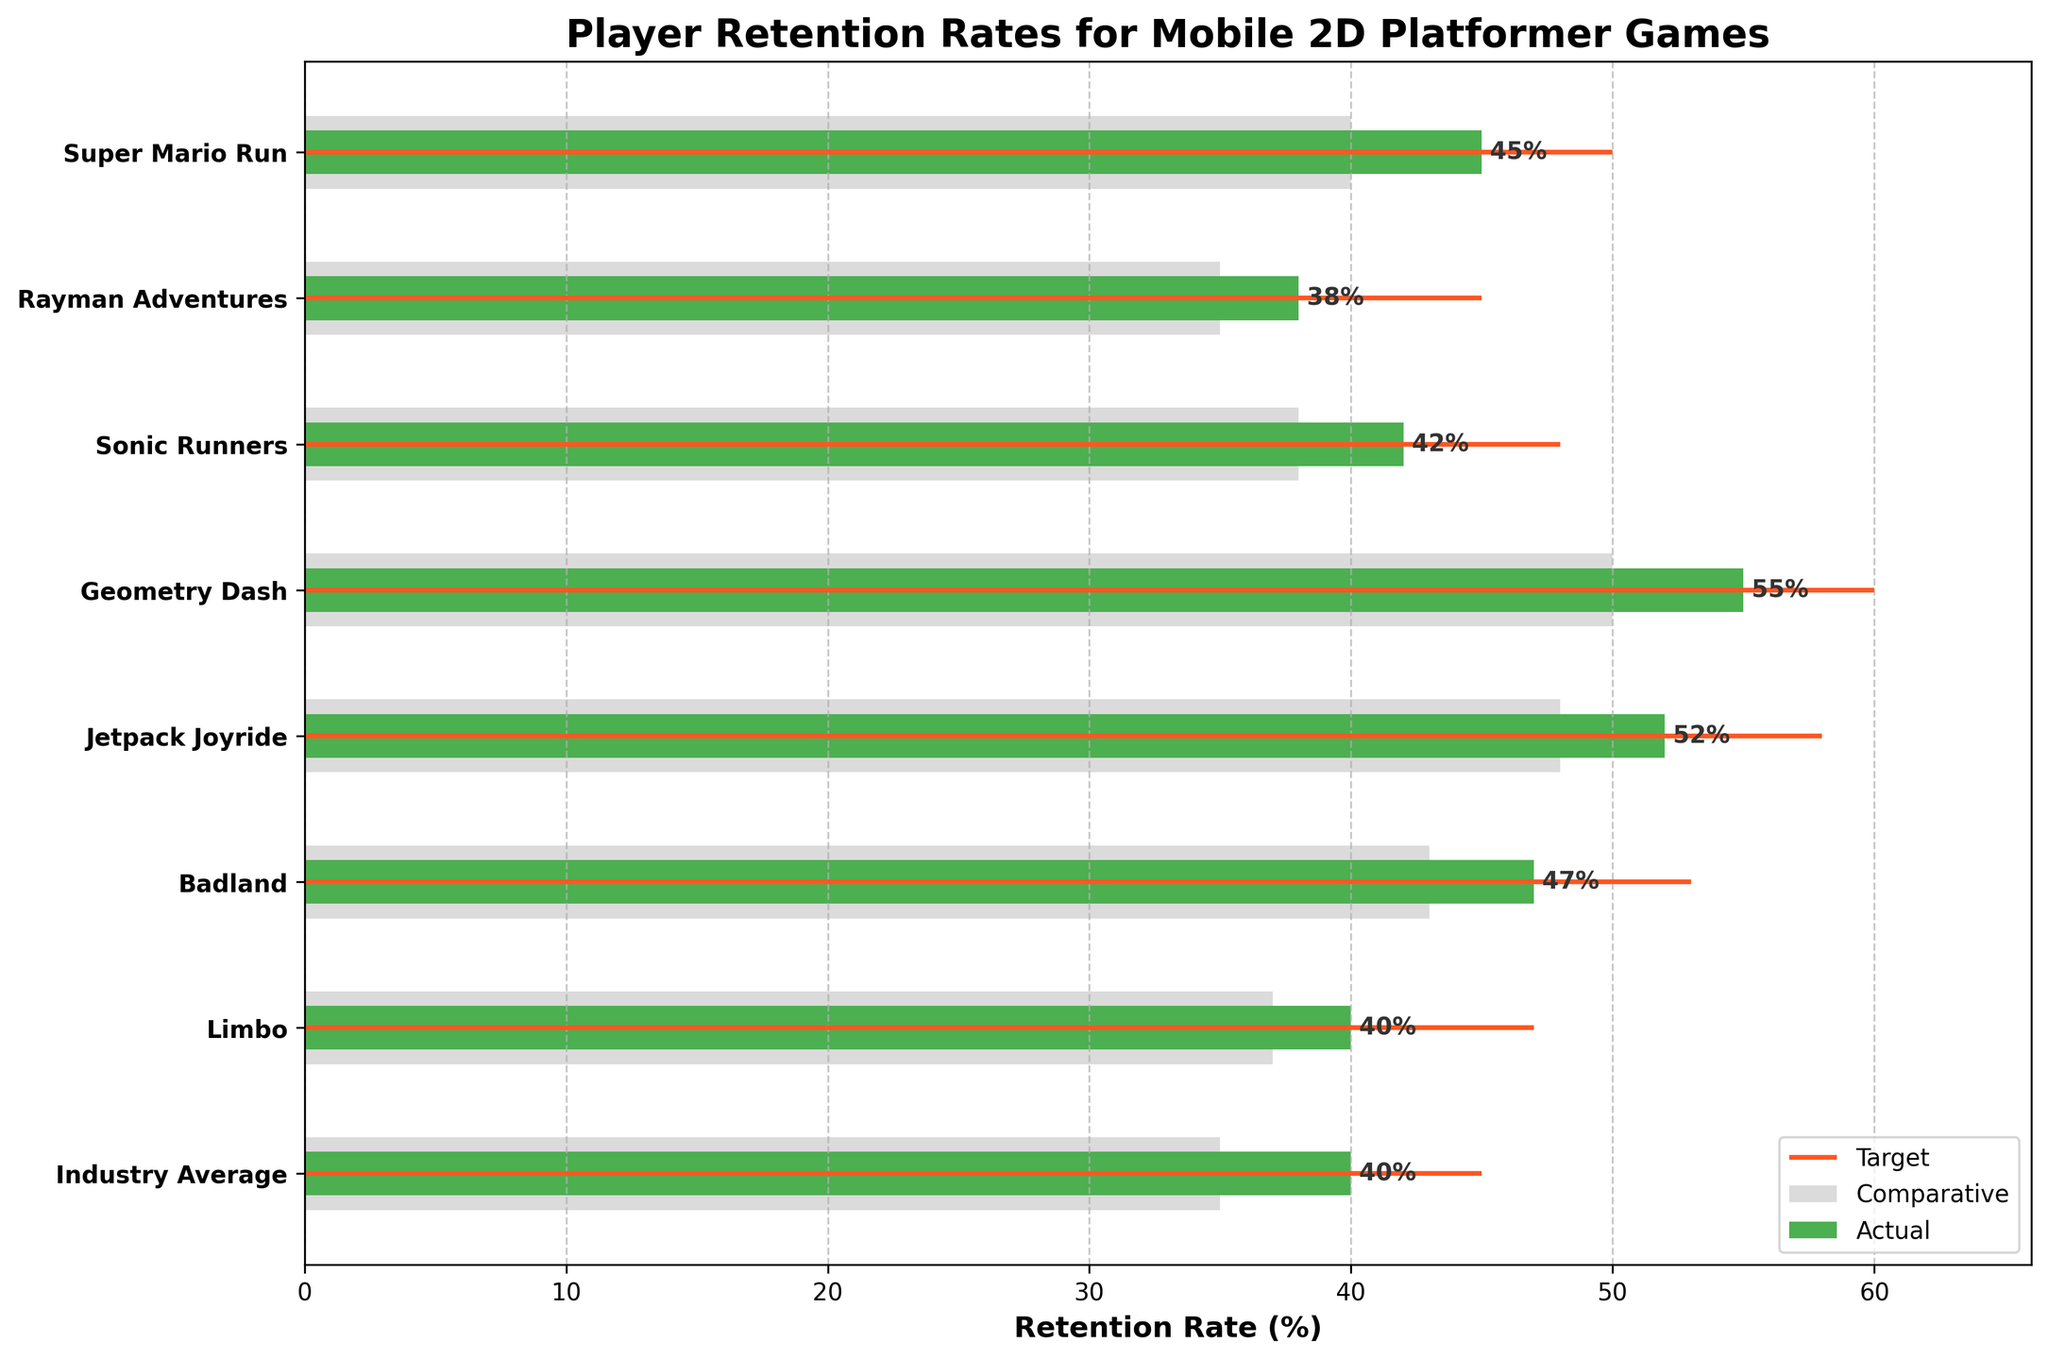What's the title of the figure? The title is prominently displayed at the top of the figure.
Answer: Player Retention Rates for Mobile 2D Platformer Games What's the retention rate for Super Mario Run compared to its target? The bar height for Super Mario Run and the target line visually indicate these values. For Super Mario Run, the actual retention rate is 45%, and the target retention rate is 50%.
Answer: 45% compared to 50% Which game has the highest actual retention rate? By comparing the heights of the green bars, Geometry Dash has the highest actual retention rate at 55%.
Answer: Geometry Dash How does the actual retention rate for Limbo compare to the industry average? The green bars for Limbo and the industry average can be directly compared. Limbo has 40%, and the industry average is 40%.
Answer: Equal (both are 40%) What's the difference between the target and actual retention rates for Jetpack Joyride? The target rate for Jetpack Joyride is 58%, and the actual rate is 52%. The difference is 58% - 52% = 6%.
Answer: 6% Which game has the smallest gap between its comparative and actual retention rates? By inspecting each game's grey and green bars, Jetpack Joyride has the smallest difference (52% actual - 48% comparative = 4%).
Answer: Jetpack Joyride What's the average actual retention rate for all games listed? Sum the actual retention rates and then divide by the number of games: (45 + 38 + 42 + 55 + 52 + 47 + 40) / 7 = 319 / 7 ≈ 45.57%.
Answer: ≈ 45.57% Are there any games where the actual retention rate is higher than the target? All target values are displayed by red lines, and none of the actual green bars exceed these.
Answer: No Which game's actual retention rate most closely matches the comparative retention rate? Close inspection reveals that Limbo has the smallest difference between actual (40%) and comparative (37%).
Answer: Limbo 